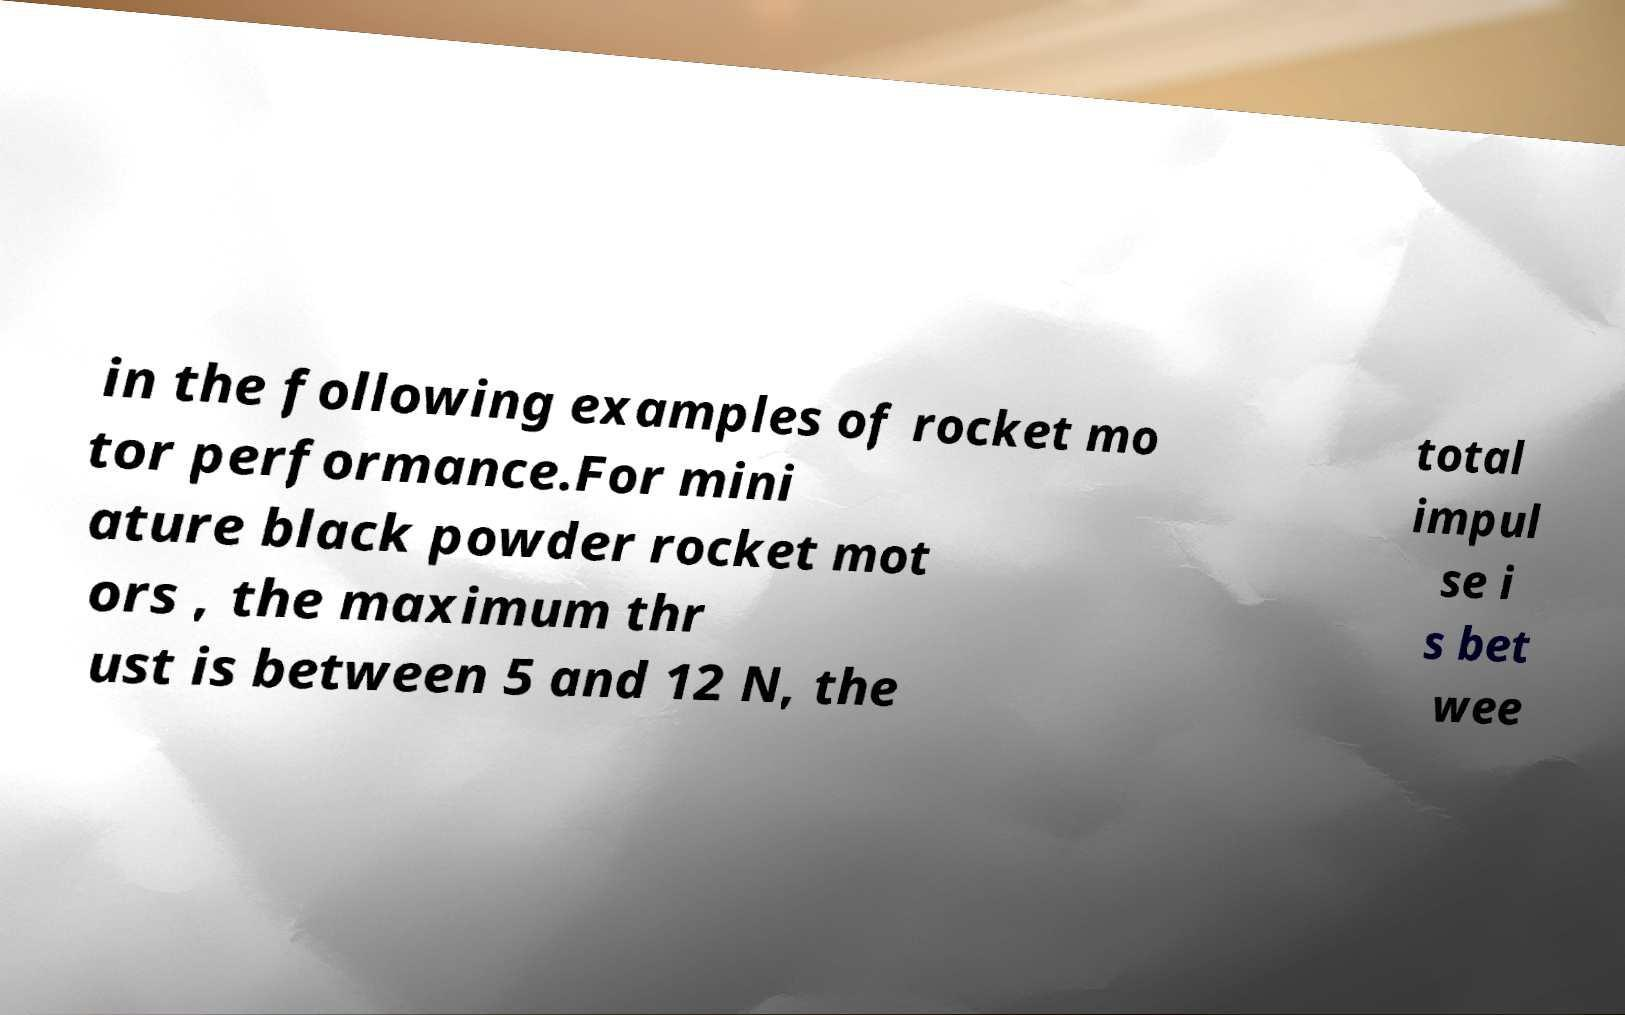What messages or text are displayed in this image? I need them in a readable, typed format. in the following examples of rocket mo tor performance.For mini ature black powder rocket mot ors , the maximum thr ust is between 5 and 12 N, the total impul se i s bet wee 